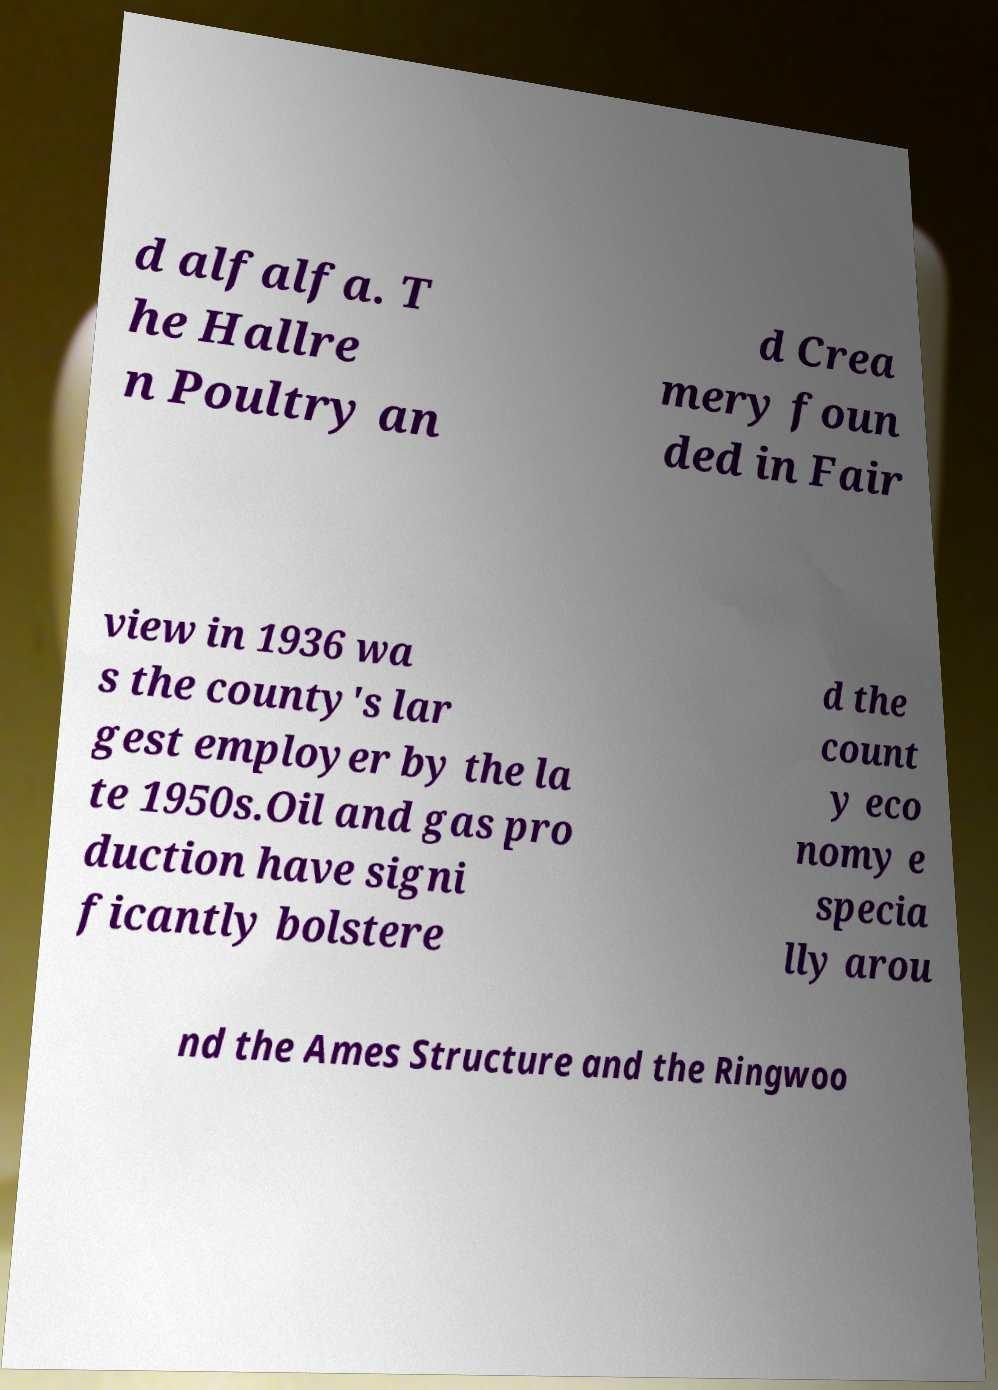Could you extract and type out the text from this image? d alfalfa. T he Hallre n Poultry an d Crea mery foun ded in Fair view in 1936 wa s the county's lar gest employer by the la te 1950s.Oil and gas pro duction have signi ficantly bolstere d the count y eco nomy e specia lly arou nd the Ames Structure and the Ringwoo 